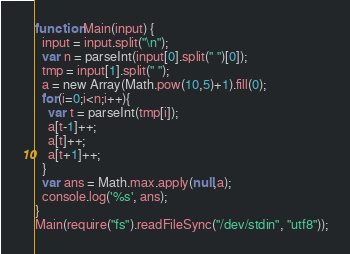<code> <loc_0><loc_0><loc_500><loc_500><_JavaScript_>function Main(input) {
  input = input.split("\n");
  var n = parseInt(input[0].split(" ")[0]);
  tmp = input[1].split(" ");
  a = new Array(Math.pow(10,5)+1).fill(0);
  for(i=0;i<n;i++){
    var t = parseInt(tmp[i]);
    a[t-1]++;
    a[t]++;
    a[t+1]++;
  }
  var ans = Math.max.apply(null,a);
  console.log('%s', ans);
}
Main(require("fs").readFileSync("/dev/stdin", "utf8"));</code> 